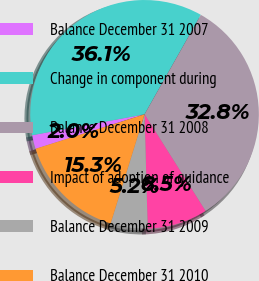<chart> <loc_0><loc_0><loc_500><loc_500><pie_chart><fcel>Balance December 31 2007<fcel>Change in component during<fcel>Balance December 31 2008<fcel>Impact of adoption of guidance<fcel>Balance December 31 2009<fcel>Balance December 31 2010<nl><fcel>1.95%<fcel>36.12%<fcel>32.84%<fcel>8.52%<fcel>5.23%<fcel>15.33%<nl></chart> 